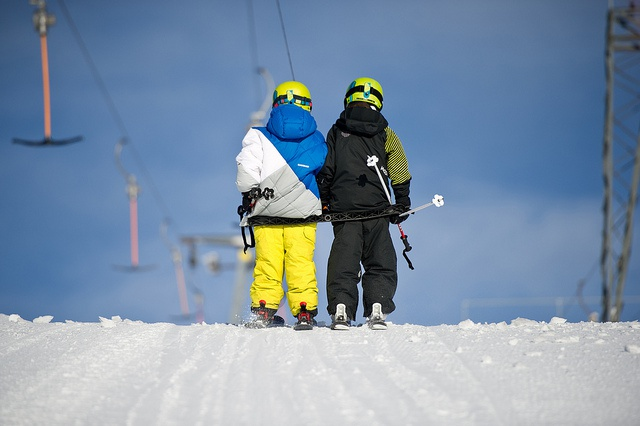Describe the objects in this image and their specific colors. I can see people in darkblue, black, darkgray, gray, and white tones, people in darkblue, gold, lightgray, black, and blue tones, skis in darkblue, darkgray, gray, and lightgray tones, and skis in darkblue, white, gray, darkgray, and black tones in this image. 